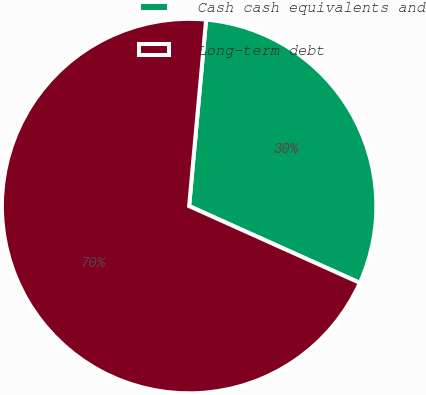Convert chart to OTSL. <chart><loc_0><loc_0><loc_500><loc_500><pie_chart><fcel>Cash cash equivalents and<fcel>Long-term debt<nl><fcel>30.28%<fcel>69.72%<nl></chart> 